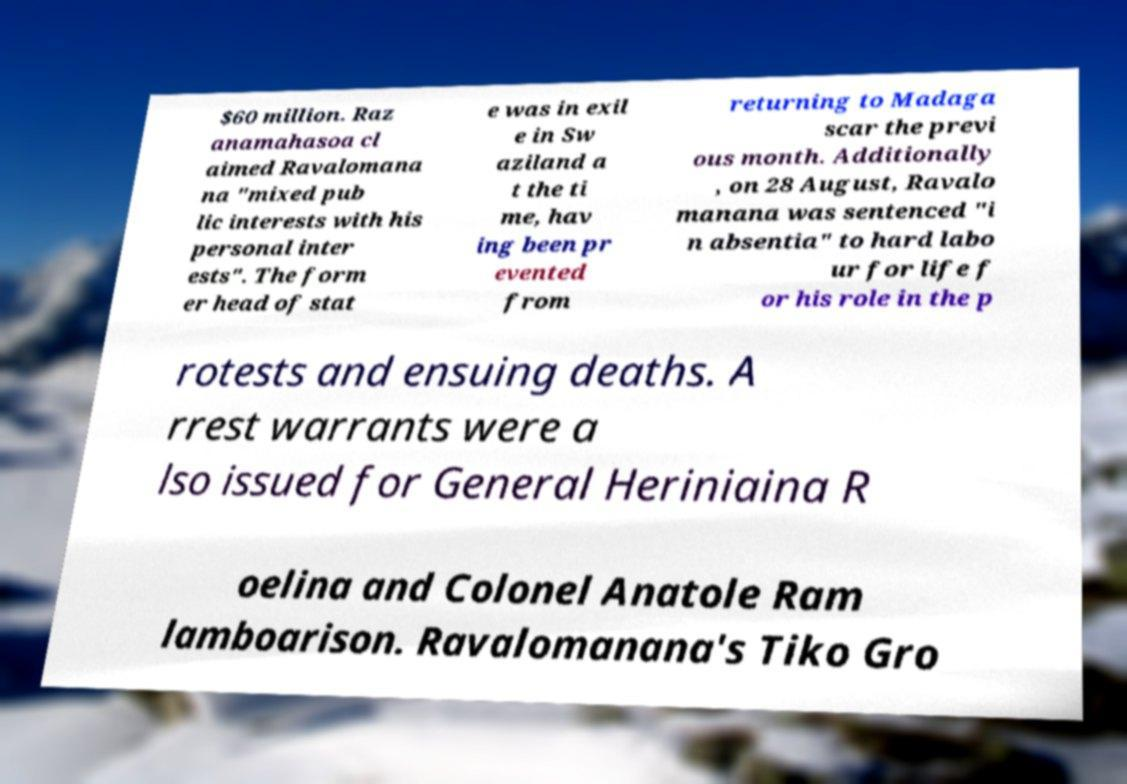I need the written content from this picture converted into text. Can you do that? $60 million. Raz anamahasoa cl aimed Ravalomana na "mixed pub lic interests with his personal inter ests". The form er head of stat e was in exil e in Sw aziland a t the ti me, hav ing been pr evented from returning to Madaga scar the previ ous month. Additionally , on 28 August, Ravalo manana was sentenced "i n absentia" to hard labo ur for life f or his role in the p rotests and ensuing deaths. A rrest warrants were a lso issued for General Heriniaina R oelina and Colonel Anatole Ram lamboarison. Ravalomanana's Tiko Gro 